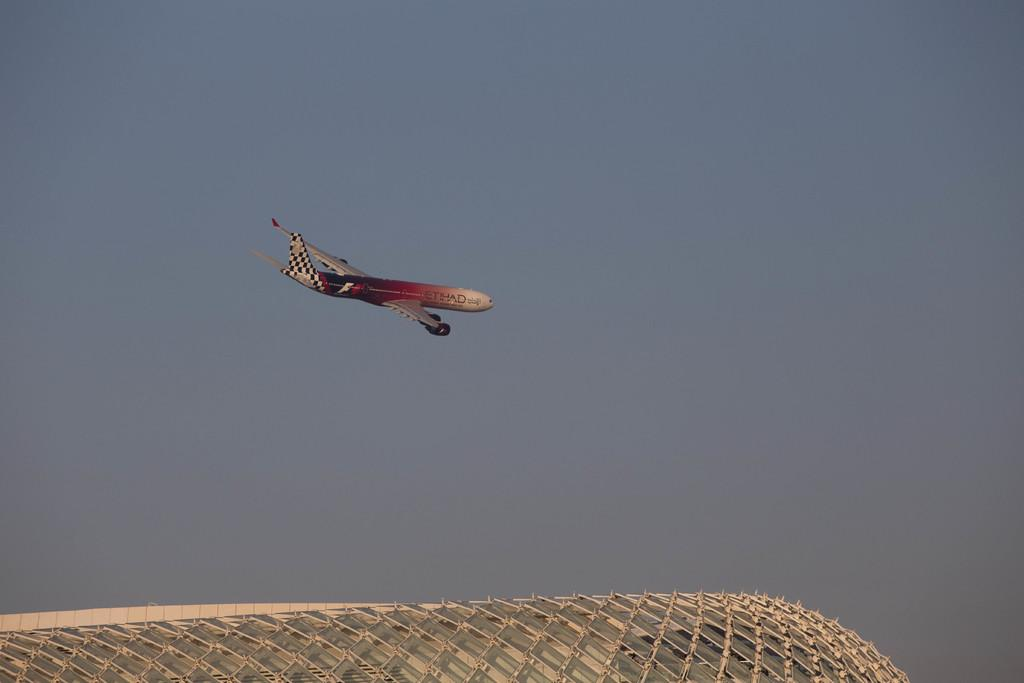What is the main subject of the image? The main subject of the image is an airplane. What is the airplane doing in the image? The airplane is flying in the sky. What can be seen on the ground in the image? There is a roof of a building in the image. What are the metal poles associated with in the image? The metal poles are associated with the building's roof. What type of crib is visible in the image? There is no crib present in the image. What shape is the head of the airplane in the image? The image does not show the head of the airplane, as it is a view from the side or back. 